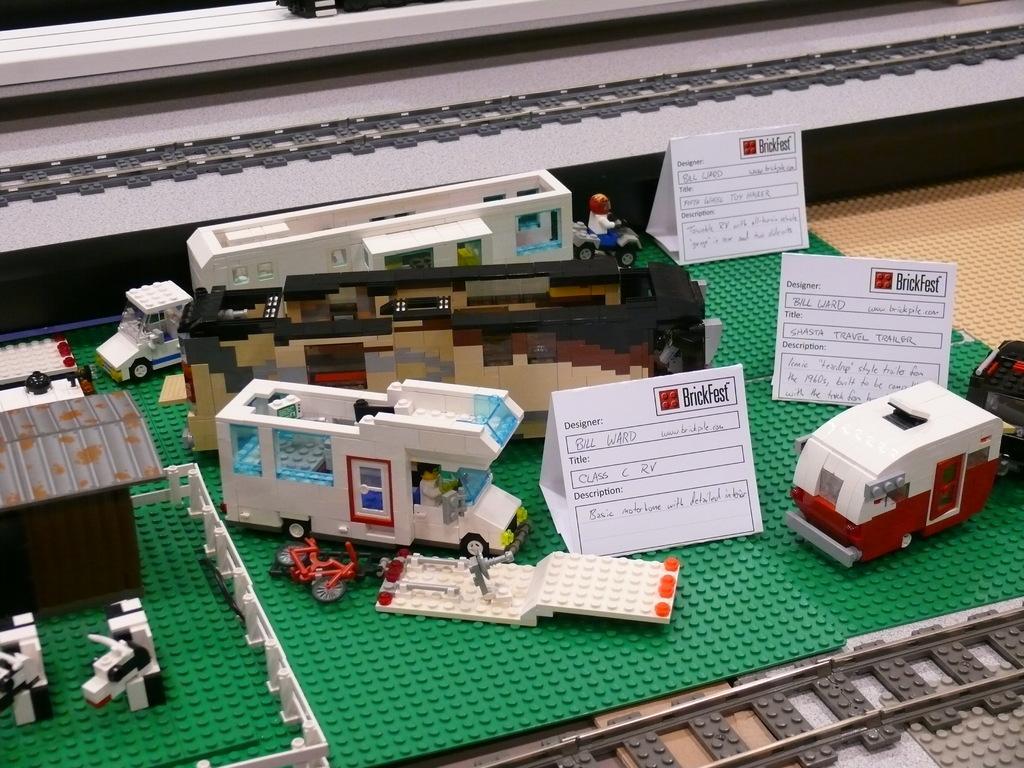How would you summarize this image in a sentence or two? In this picture we can see lego toys and lego boards. On the lego boards there are some white boards. 